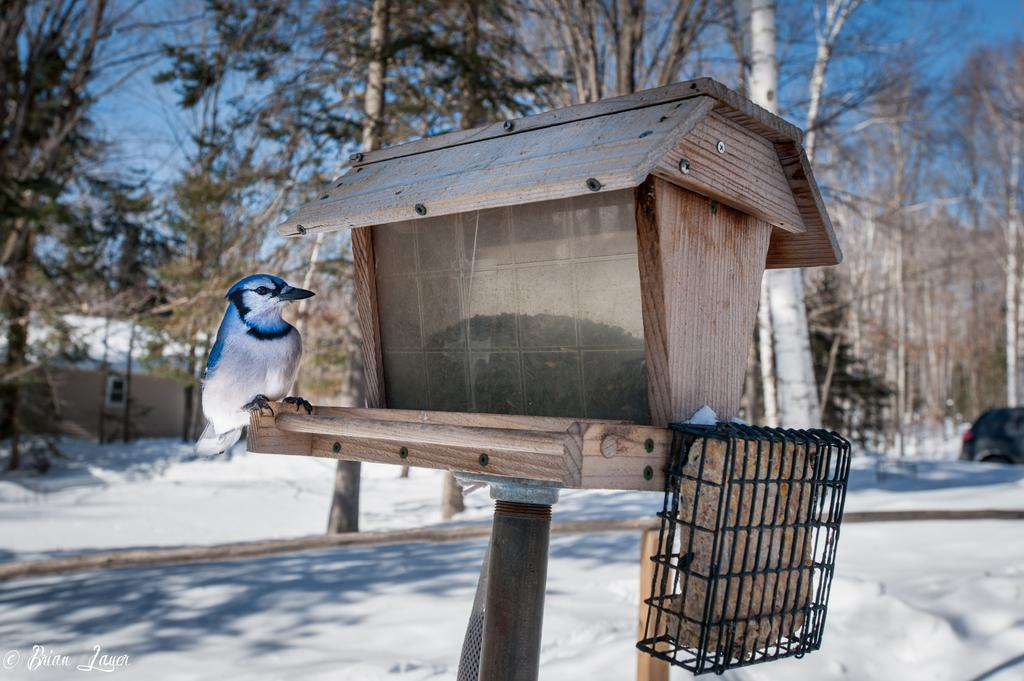What type of bird house is in the image? There is a brown color small bird house in the image. How is the bird house positioned? The bird house is placed on a pipe. Is there a bird near the bird house? Yes, there is a bird sitting beside the bird house. What can be seen in the background of the image? Dry trees and snow on the ground are visible in the background of the image. What is the bird's belief about the number of times it can swim in the snow? There is no indication of the bird swimming in the snow, nor is there any information about its beliefs in the image. 